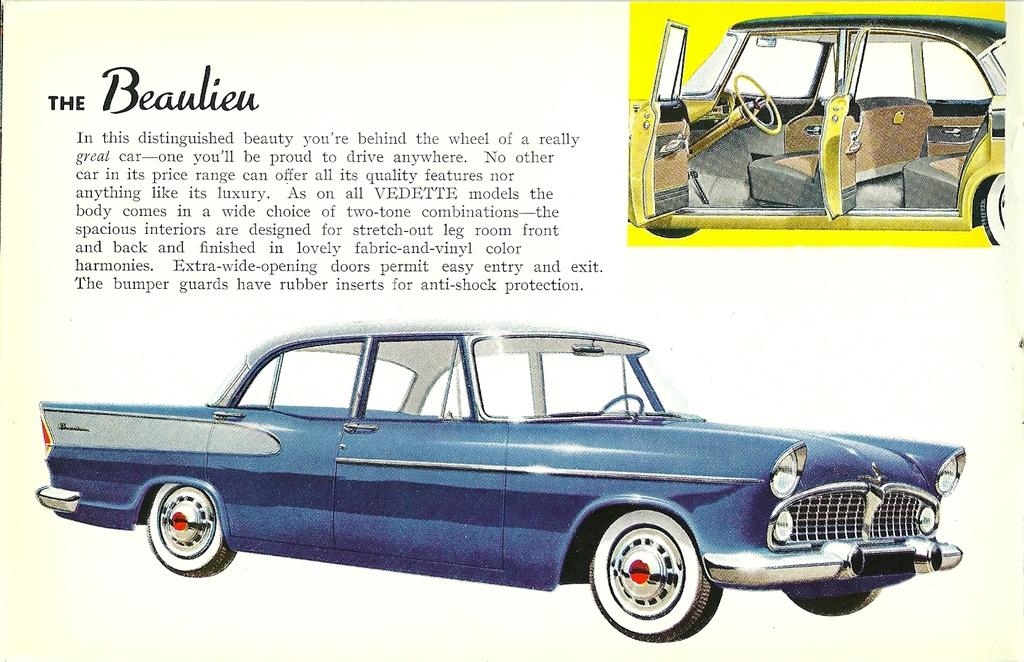What type of visual is the image? The image is a poster. What can be seen at the bottom of the poster? There is a blue color car at the bottom of the poster. What is located on the right side of the poster? There is a yellow color car on the right side of the poster. Where is the text positioned on the poster? The text is on the left side of the poster. What type of hole can be seen in the poster? There is no hole present in the poster; it is a flat visual with no holes or openings. 